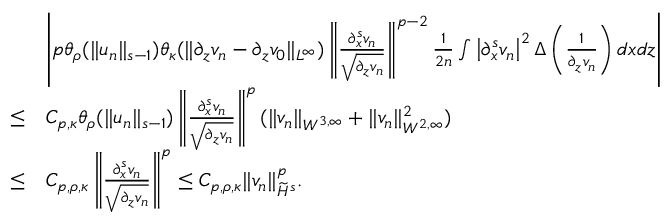Convert formula to latex. <formula><loc_0><loc_0><loc_500><loc_500>\begin{array} { r l } & { \left | p \theta _ { \rho } ( \| u _ { n } \| _ { s - 1 } ) \theta _ { \kappa } ( \| \partial _ { z } v _ { n } - \partial _ { z } v _ { 0 } \| _ { L ^ { \infty } } ) \left \| \frac { \partial _ { x } ^ { s } v _ { n } } { \sqrt { \partial _ { z } v _ { n } } } \right \| ^ { p - 2 } \frac { 1 } 2 n } \int \left | \partial _ { x } ^ { s } v _ { n } \right | ^ { 2 } \Delta \left ( \frac { 1 } \partial _ { z } v _ { n } } \right ) d x d z \right | } \\ { \leq } & { C _ { p , \kappa } \theta _ { \rho } ( \| u _ { n } \| _ { s - 1 } ) \left \| \frac { \partial _ { x } ^ { s } v _ { n } } { \sqrt { \partial _ { z } v _ { n } } } \right \| ^ { p } ( \| v _ { n } \| _ { W ^ { 3 , \infty } } + \| v _ { n } \| _ { W ^ { 2 , \infty } } ^ { 2 } ) } \\ { \leq } & { C _ { p , \rho , \kappa } \left \| \frac { \partial _ { x } ^ { s } v _ { n } } { \sqrt { \partial _ { z } v _ { n } } } \right \| ^ { p } \leq C _ { p , \rho , \kappa } \| v _ { n } \| _ { \widetilde { H } ^ { s } } ^ { p } . } \end{array}</formula> 